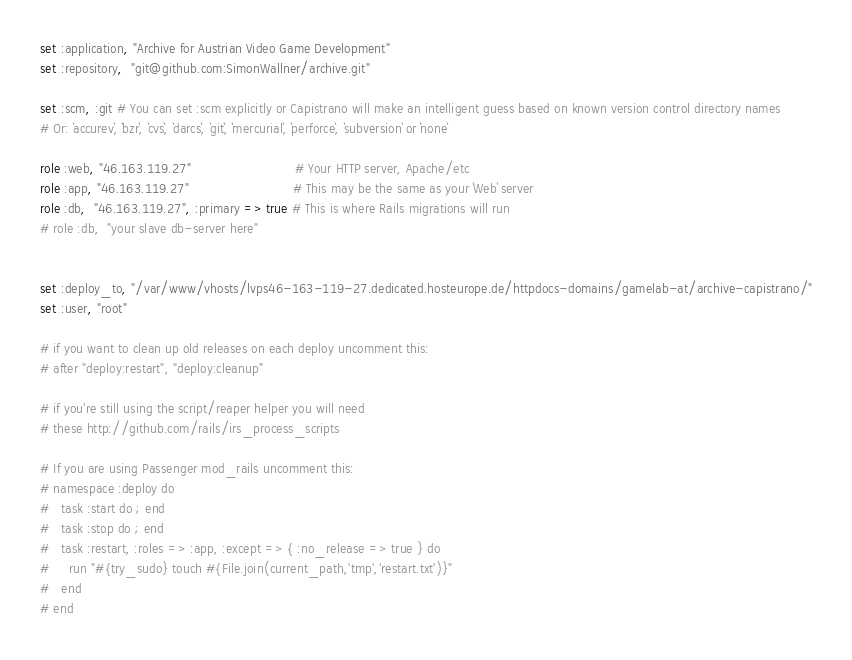<code> <loc_0><loc_0><loc_500><loc_500><_Ruby_>set :application, "Archive for Austrian Video Game Development"
set :repository,  "git@github.com:SimonWallner/archive.git"

set :scm, :git # You can set :scm explicitly or Capistrano will make an intelligent guess based on known version control directory names
# Or: `accurev`, `bzr`, `cvs`, `darcs`, `git`, `mercurial`, `perforce`, `subversion` or `none`

role :web, "46.163.119.27"                          # Your HTTP server, Apache/etc
role :app, "46.163.119.27"                          # This may be the same as your `Web` server
role :db,  "46.163.119.27", :primary => true # This is where Rails migrations will run
# role :db,  "your slave db-server here"


set :deploy_to, "/var/www/vhosts/lvps46-163-119-27.dedicated.hosteurope.de/httpdocs-domains/gamelab-at/archive-capistrano/"
set :user, "root"

# if you want to clean up old releases on each deploy uncomment this:
# after "deploy:restart", "deploy:cleanup"

# if you're still using the script/reaper helper you will need
# these http://github.com/rails/irs_process_scripts

# If you are using Passenger mod_rails uncomment this:
# namespace :deploy do
#   task :start do ; end
#   task :stop do ; end
#   task :restart, :roles => :app, :except => { :no_release => true } do
#     run "#{try_sudo} touch #{File.join(current_path,'tmp','restart.txt')}"
#   end
# end</code> 